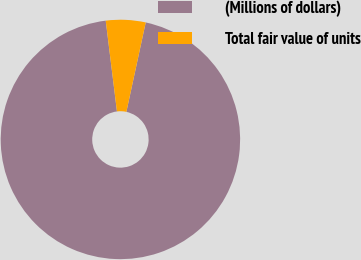Convert chart. <chart><loc_0><loc_0><loc_500><loc_500><pie_chart><fcel>(Millions of dollars)<fcel>Total fair value of units<nl><fcel>94.65%<fcel>5.35%<nl></chart> 